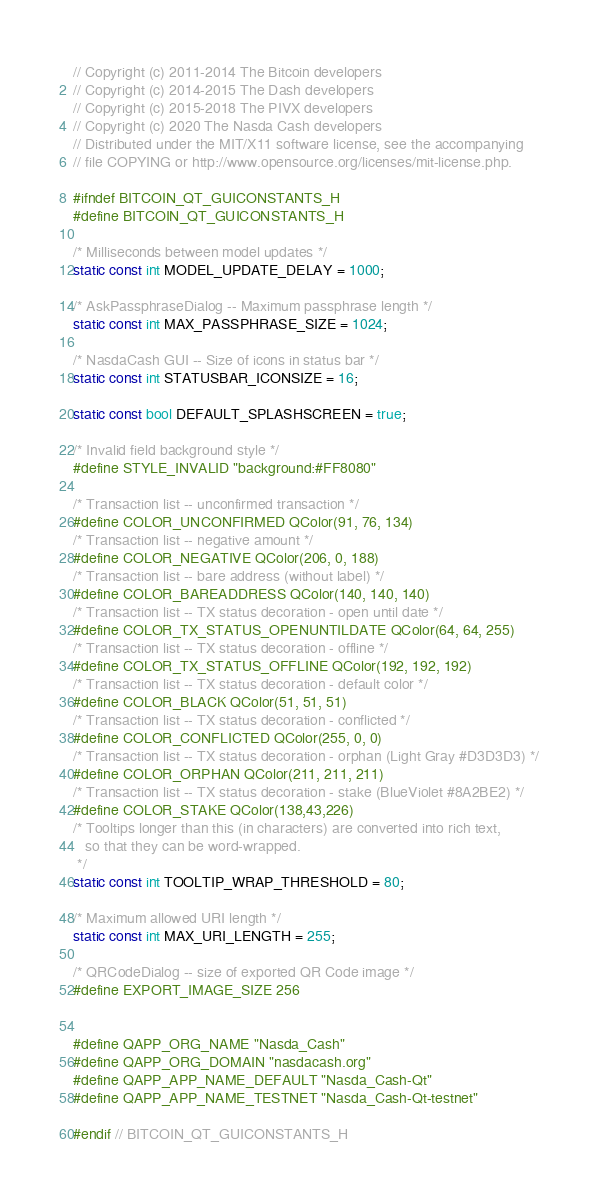Convert code to text. <code><loc_0><loc_0><loc_500><loc_500><_C_>// Copyright (c) 2011-2014 The Bitcoin developers
// Copyright (c) 2014-2015 The Dash developers
// Copyright (c) 2015-2018 The PIVX developers
// Copyright (c) 2020 The Nasda Cash developers
// Distributed under the MIT/X11 software license, see the accompanying
// file COPYING or http://www.opensource.org/licenses/mit-license.php.

#ifndef BITCOIN_QT_GUICONSTANTS_H
#define BITCOIN_QT_GUICONSTANTS_H

/* Milliseconds between model updates */
static const int MODEL_UPDATE_DELAY = 1000;

/* AskPassphraseDialog -- Maximum passphrase length */
static const int MAX_PASSPHRASE_SIZE = 1024;

/* NasdaCash GUI -- Size of icons in status bar */
static const int STATUSBAR_ICONSIZE = 16;

static const bool DEFAULT_SPLASHSCREEN = true;

/* Invalid field background style */
#define STYLE_INVALID "background:#FF8080"

/* Transaction list -- unconfirmed transaction */
#define COLOR_UNCONFIRMED QColor(91, 76, 134)
/* Transaction list -- negative amount */
#define COLOR_NEGATIVE QColor(206, 0, 188)
/* Transaction list -- bare address (without label) */
#define COLOR_BAREADDRESS QColor(140, 140, 140)
/* Transaction list -- TX status decoration - open until date */
#define COLOR_TX_STATUS_OPENUNTILDATE QColor(64, 64, 255)
/* Transaction list -- TX status decoration - offline */
#define COLOR_TX_STATUS_OFFLINE QColor(192, 192, 192)
/* Transaction list -- TX status decoration - default color */
#define COLOR_BLACK QColor(51, 51, 51)
/* Transaction list -- TX status decoration - conflicted */
#define COLOR_CONFLICTED QColor(255, 0, 0)
/* Transaction list -- TX status decoration - orphan (Light Gray #D3D3D3) */
#define COLOR_ORPHAN QColor(211, 211, 211)
/* Transaction list -- TX status decoration - stake (BlueViolet #8A2BE2) */
#define COLOR_STAKE QColor(138,43,226)
/* Tooltips longer than this (in characters) are converted into rich text,
   so that they can be word-wrapped.
 */
static const int TOOLTIP_WRAP_THRESHOLD = 80;

/* Maximum allowed URI length */
static const int MAX_URI_LENGTH = 255;

/* QRCodeDialog -- size of exported QR Code image */
#define EXPORT_IMAGE_SIZE 256


#define QAPP_ORG_NAME "Nasda_Cash"
#define QAPP_ORG_DOMAIN "nasdacash.org"
#define QAPP_APP_NAME_DEFAULT "Nasda_Cash-Qt"
#define QAPP_APP_NAME_TESTNET "Nasda_Cash-Qt-testnet"

#endif // BITCOIN_QT_GUICONSTANTS_H
</code> 